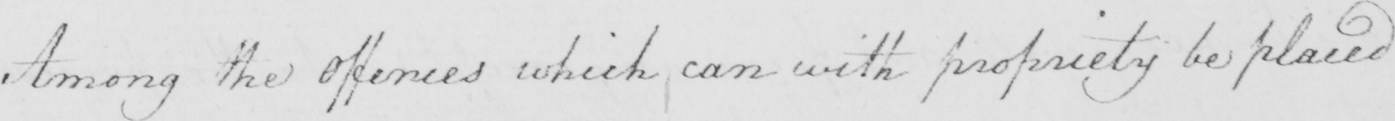Can you tell me what this handwritten text says? Among the Offences which can with propriety be placed 